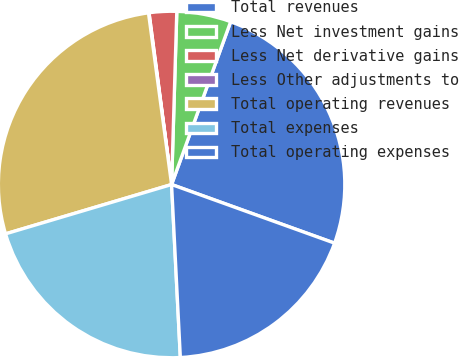<chart> <loc_0><loc_0><loc_500><loc_500><pie_chart><fcel>Total revenues<fcel>Less Net investment gains<fcel>Less Net derivative gains<fcel>Less Other adjustments to<fcel>Total operating revenues<fcel>Total expenses<fcel>Total operating expenses<nl><fcel>24.96%<fcel>5.06%<fcel>2.56%<fcel>0.05%<fcel>27.47%<fcel>21.21%<fcel>18.7%<nl></chart> 